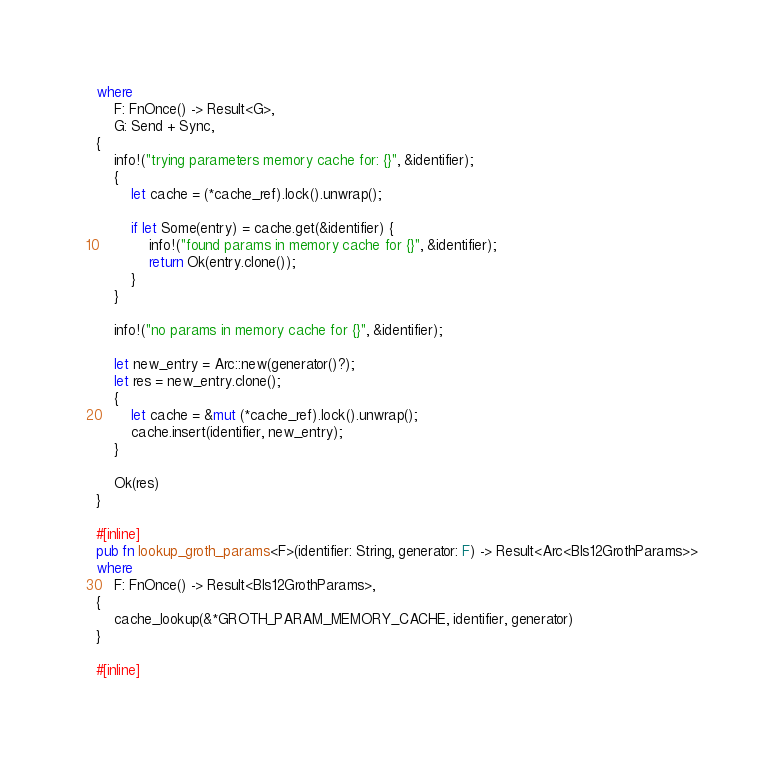<code> <loc_0><loc_0><loc_500><loc_500><_Rust_>where
    F: FnOnce() -> Result<G>,
    G: Send + Sync,
{
    info!("trying parameters memory cache for: {}", &identifier);
    {
        let cache = (*cache_ref).lock().unwrap();

        if let Some(entry) = cache.get(&identifier) {
            info!("found params in memory cache for {}", &identifier);
            return Ok(entry.clone());
        }
    }

    info!("no params in memory cache for {}", &identifier);

    let new_entry = Arc::new(generator()?);
    let res = new_entry.clone();
    {
        let cache = &mut (*cache_ref).lock().unwrap();
        cache.insert(identifier, new_entry);
    }

    Ok(res)
}

#[inline]
pub fn lookup_groth_params<F>(identifier: String, generator: F) -> Result<Arc<Bls12GrothParams>>
where
    F: FnOnce() -> Result<Bls12GrothParams>,
{
    cache_lookup(&*GROTH_PARAM_MEMORY_CACHE, identifier, generator)
}

#[inline]</code> 